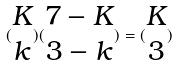<formula> <loc_0><loc_0><loc_500><loc_500>( \begin{matrix} K \\ k \end{matrix} ) ( \begin{matrix} 7 - K \\ 3 - k \end{matrix} ) = ( \begin{matrix} K \\ 3 \end{matrix} )</formula> 